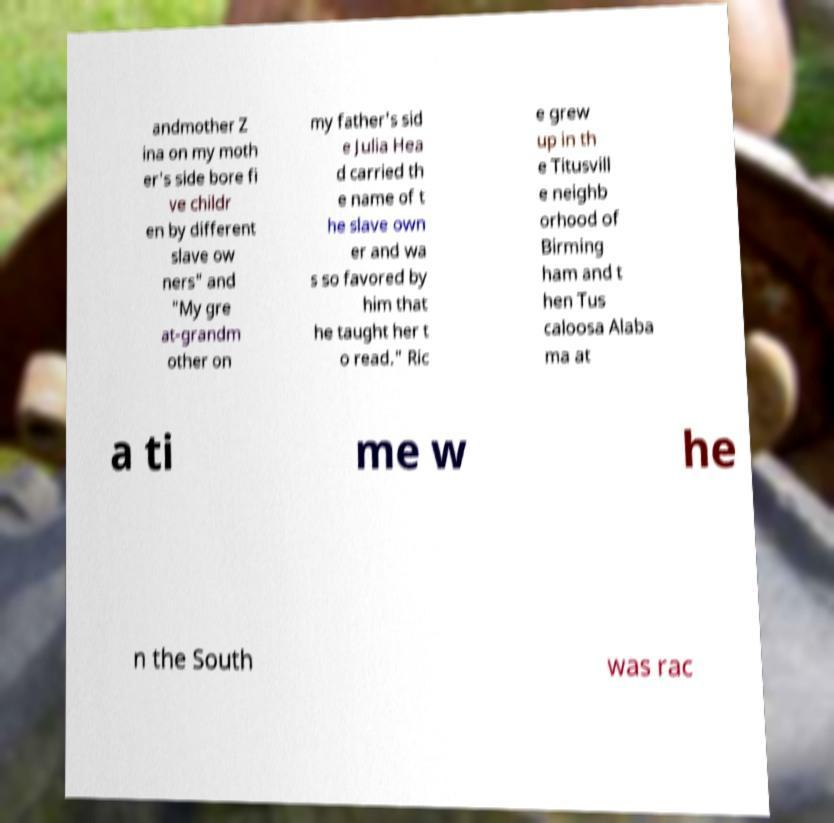Could you extract and type out the text from this image? andmother Z ina on my moth er's side bore fi ve childr en by different slave ow ners" and "My gre at-grandm other on my father's sid e Julia Hea d carried th e name of t he slave own er and wa s so favored by him that he taught her t o read." Ric e grew up in th e Titusvill e neighb orhood of Birming ham and t hen Tus caloosa Alaba ma at a ti me w he n the South was rac 